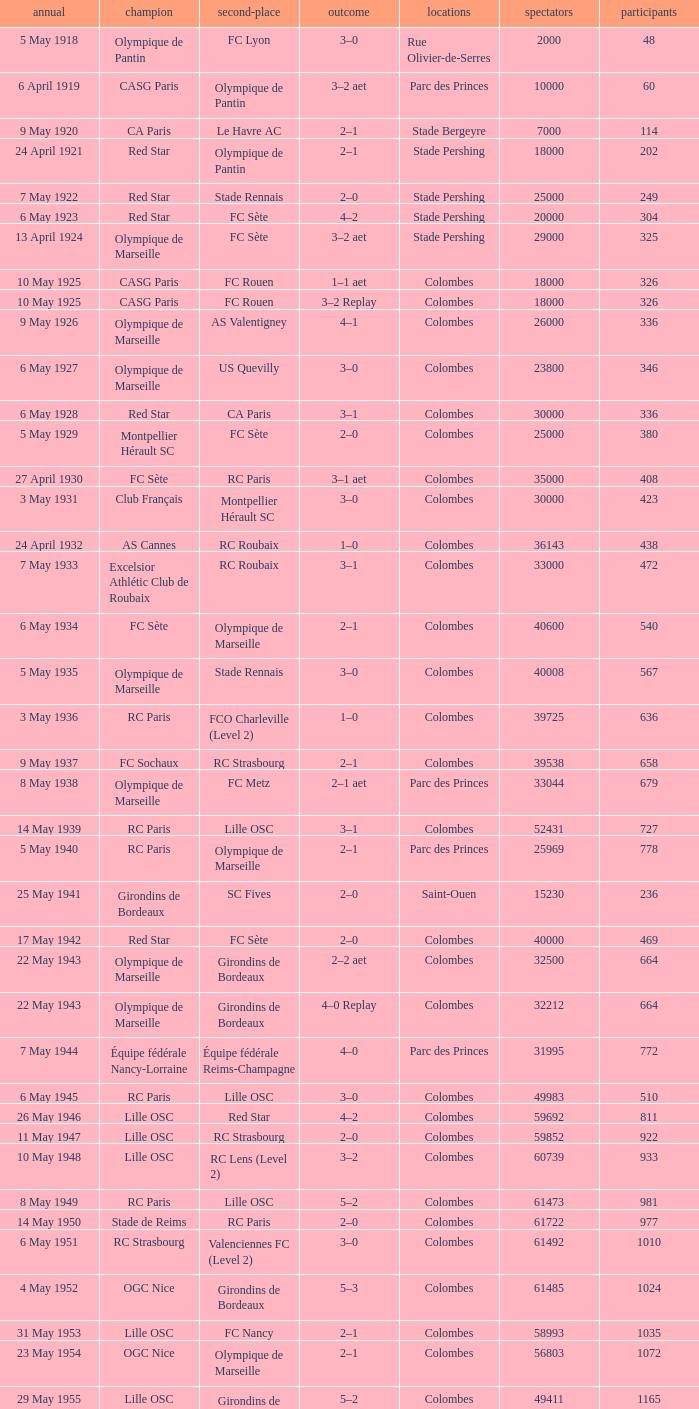What is the fewest recorded entrants against paris saint-germain? 6394.0. 